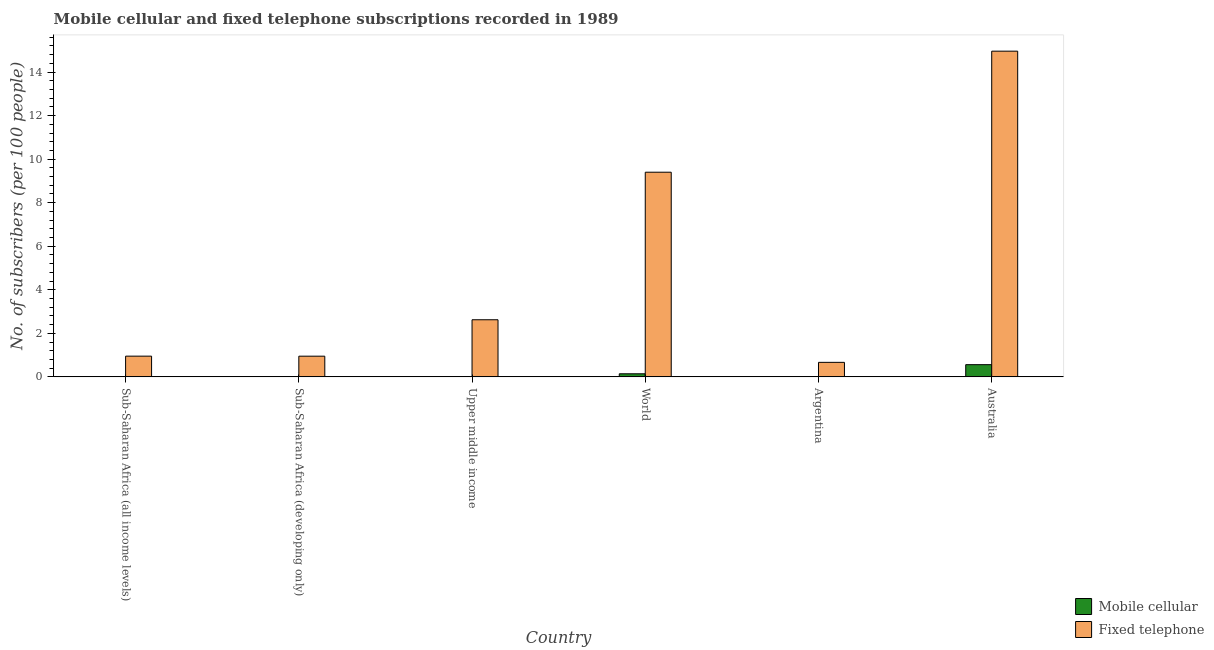How many different coloured bars are there?
Provide a short and direct response. 2. How many groups of bars are there?
Give a very brief answer. 6. Are the number of bars on each tick of the X-axis equal?
Your response must be concise. Yes. How many bars are there on the 3rd tick from the left?
Offer a very short reply. 2. How many bars are there on the 3rd tick from the right?
Provide a short and direct response. 2. What is the number of fixed telephone subscribers in Upper middle income?
Ensure brevity in your answer.  2.62. Across all countries, what is the maximum number of fixed telephone subscribers?
Make the answer very short. 14.96. Across all countries, what is the minimum number of fixed telephone subscribers?
Offer a very short reply. 0.67. What is the total number of fixed telephone subscribers in the graph?
Your response must be concise. 29.55. What is the difference between the number of mobile cellular subscribers in Australia and that in World?
Offer a very short reply. 0.42. What is the difference between the number of fixed telephone subscribers in Sub-Saharan Africa (all income levels) and the number of mobile cellular subscribers in Argentina?
Make the answer very short. 0.94. What is the average number of fixed telephone subscribers per country?
Ensure brevity in your answer.  4.93. What is the difference between the number of mobile cellular subscribers and number of fixed telephone subscribers in World?
Your answer should be very brief. -9.26. In how many countries, is the number of fixed telephone subscribers greater than 4.4 ?
Offer a very short reply. 2. What is the ratio of the number of fixed telephone subscribers in Australia to that in Sub-Saharan Africa (developing only)?
Your answer should be compact. 15.74. Is the difference between the number of mobile cellular subscribers in Australia and Upper middle income greater than the difference between the number of fixed telephone subscribers in Australia and Upper middle income?
Your answer should be very brief. No. What is the difference between the highest and the second highest number of mobile cellular subscribers?
Your response must be concise. 0.42. What is the difference between the highest and the lowest number of fixed telephone subscribers?
Your response must be concise. 14.29. In how many countries, is the number of fixed telephone subscribers greater than the average number of fixed telephone subscribers taken over all countries?
Offer a very short reply. 2. Is the sum of the number of fixed telephone subscribers in Argentina and Australia greater than the maximum number of mobile cellular subscribers across all countries?
Provide a succinct answer. Yes. What does the 1st bar from the left in Upper middle income represents?
Give a very brief answer. Mobile cellular. What does the 1st bar from the right in Sub-Saharan Africa (all income levels) represents?
Ensure brevity in your answer.  Fixed telephone. How many bars are there?
Keep it short and to the point. 12. Are all the bars in the graph horizontal?
Offer a terse response. No. How many countries are there in the graph?
Provide a succinct answer. 6. Does the graph contain grids?
Provide a succinct answer. No. How many legend labels are there?
Give a very brief answer. 2. How are the legend labels stacked?
Your answer should be very brief. Vertical. What is the title of the graph?
Make the answer very short. Mobile cellular and fixed telephone subscriptions recorded in 1989. What is the label or title of the Y-axis?
Ensure brevity in your answer.  No. of subscribers (per 100 people). What is the No. of subscribers (per 100 people) in Mobile cellular in Sub-Saharan Africa (all income levels)?
Provide a short and direct response. 0. What is the No. of subscribers (per 100 people) in Fixed telephone in Sub-Saharan Africa (all income levels)?
Give a very brief answer. 0.95. What is the No. of subscribers (per 100 people) of Mobile cellular in Sub-Saharan Africa (developing only)?
Provide a succinct answer. 0. What is the No. of subscribers (per 100 people) in Fixed telephone in Sub-Saharan Africa (developing only)?
Offer a very short reply. 0.95. What is the No. of subscribers (per 100 people) of Mobile cellular in Upper middle income?
Give a very brief answer. 0.01. What is the No. of subscribers (per 100 people) of Fixed telephone in Upper middle income?
Make the answer very short. 2.62. What is the No. of subscribers (per 100 people) of Mobile cellular in World?
Your response must be concise. 0.14. What is the No. of subscribers (per 100 people) of Fixed telephone in World?
Make the answer very short. 9.4. What is the No. of subscribers (per 100 people) of Mobile cellular in Argentina?
Your answer should be compact. 0.01. What is the No. of subscribers (per 100 people) of Fixed telephone in Argentina?
Provide a short and direct response. 0.67. What is the No. of subscribers (per 100 people) of Mobile cellular in Australia?
Your answer should be compact. 0.56. What is the No. of subscribers (per 100 people) in Fixed telephone in Australia?
Keep it short and to the point. 14.96. Across all countries, what is the maximum No. of subscribers (per 100 people) in Mobile cellular?
Ensure brevity in your answer.  0.56. Across all countries, what is the maximum No. of subscribers (per 100 people) of Fixed telephone?
Keep it short and to the point. 14.96. Across all countries, what is the minimum No. of subscribers (per 100 people) in Mobile cellular?
Make the answer very short. 0. Across all countries, what is the minimum No. of subscribers (per 100 people) of Fixed telephone?
Provide a short and direct response. 0.67. What is the total No. of subscribers (per 100 people) of Mobile cellular in the graph?
Ensure brevity in your answer.  0.72. What is the total No. of subscribers (per 100 people) of Fixed telephone in the graph?
Offer a terse response. 29.55. What is the difference between the No. of subscribers (per 100 people) in Fixed telephone in Sub-Saharan Africa (all income levels) and that in Sub-Saharan Africa (developing only)?
Your answer should be compact. 0. What is the difference between the No. of subscribers (per 100 people) in Mobile cellular in Sub-Saharan Africa (all income levels) and that in Upper middle income?
Offer a terse response. -0.01. What is the difference between the No. of subscribers (per 100 people) in Fixed telephone in Sub-Saharan Africa (all income levels) and that in Upper middle income?
Your response must be concise. -1.67. What is the difference between the No. of subscribers (per 100 people) of Mobile cellular in Sub-Saharan Africa (all income levels) and that in World?
Ensure brevity in your answer.  -0.14. What is the difference between the No. of subscribers (per 100 people) of Fixed telephone in Sub-Saharan Africa (all income levels) and that in World?
Keep it short and to the point. -8.45. What is the difference between the No. of subscribers (per 100 people) of Mobile cellular in Sub-Saharan Africa (all income levels) and that in Argentina?
Offer a very short reply. -0.01. What is the difference between the No. of subscribers (per 100 people) in Fixed telephone in Sub-Saharan Africa (all income levels) and that in Argentina?
Make the answer very short. 0.28. What is the difference between the No. of subscribers (per 100 people) of Mobile cellular in Sub-Saharan Africa (all income levels) and that in Australia?
Your answer should be very brief. -0.56. What is the difference between the No. of subscribers (per 100 people) in Fixed telephone in Sub-Saharan Africa (all income levels) and that in Australia?
Provide a short and direct response. -14.01. What is the difference between the No. of subscribers (per 100 people) in Mobile cellular in Sub-Saharan Africa (developing only) and that in Upper middle income?
Offer a very short reply. -0.01. What is the difference between the No. of subscribers (per 100 people) of Fixed telephone in Sub-Saharan Africa (developing only) and that in Upper middle income?
Give a very brief answer. -1.67. What is the difference between the No. of subscribers (per 100 people) of Mobile cellular in Sub-Saharan Africa (developing only) and that in World?
Give a very brief answer. -0.14. What is the difference between the No. of subscribers (per 100 people) of Fixed telephone in Sub-Saharan Africa (developing only) and that in World?
Ensure brevity in your answer.  -8.45. What is the difference between the No. of subscribers (per 100 people) in Mobile cellular in Sub-Saharan Africa (developing only) and that in Argentina?
Provide a short and direct response. -0.01. What is the difference between the No. of subscribers (per 100 people) of Fixed telephone in Sub-Saharan Africa (developing only) and that in Argentina?
Provide a succinct answer. 0.28. What is the difference between the No. of subscribers (per 100 people) in Mobile cellular in Sub-Saharan Africa (developing only) and that in Australia?
Your response must be concise. -0.56. What is the difference between the No. of subscribers (per 100 people) of Fixed telephone in Sub-Saharan Africa (developing only) and that in Australia?
Provide a succinct answer. -14.01. What is the difference between the No. of subscribers (per 100 people) in Mobile cellular in Upper middle income and that in World?
Your response must be concise. -0.14. What is the difference between the No. of subscribers (per 100 people) of Fixed telephone in Upper middle income and that in World?
Provide a succinct answer. -6.78. What is the difference between the No. of subscribers (per 100 people) of Mobile cellular in Upper middle income and that in Argentina?
Your answer should be very brief. -0. What is the difference between the No. of subscribers (per 100 people) in Fixed telephone in Upper middle income and that in Argentina?
Offer a very short reply. 1.96. What is the difference between the No. of subscribers (per 100 people) in Mobile cellular in Upper middle income and that in Australia?
Your answer should be very brief. -0.55. What is the difference between the No. of subscribers (per 100 people) in Fixed telephone in Upper middle income and that in Australia?
Provide a succinct answer. -12.34. What is the difference between the No. of subscribers (per 100 people) in Mobile cellular in World and that in Argentina?
Offer a very short reply. 0.13. What is the difference between the No. of subscribers (per 100 people) in Fixed telephone in World and that in Argentina?
Ensure brevity in your answer.  8.73. What is the difference between the No. of subscribers (per 100 people) of Mobile cellular in World and that in Australia?
Give a very brief answer. -0.42. What is the difference between the No. of subscribers (per 100 people) in Fixed telephone in World and that in Australia?
Provide a short and direct response. -5.56. What is the difference between the No. of subscribers (per 100 people) of Mobile cellular in Argentina and that in Australia?
Keep it short and to the point. -0.55. What is the difference between the No. of subscribers (per 100 people) in Fixed telephone in Argentina and that in Australia?
Make the answer very short. -14.29. What is the difference between the No. of subscribers (per 100 people) of Mobile cellular in Sub-Saharan Africa (all income levels) and the No. of subscribers (per 100 people) of Fixed telephone in Sub-Saharan Africa (developing only)?
Ensure brevity in your answer.  -0.95. What is the difference between the No. of subscribers (per 100 people) in Mobile cellular in Sub-Saharan Africa (all income levels) and the No. of subscribers (per 100 people) in Fixed telephone in Upper middle income?
Provide a succinct answer. -2.62. What is the difference between the No. of subscribers (per 100 people) of Mobile cellular in Sub-Saharan Africa (all income levels) and the No. of subscribers (per 100 people) of Fixed telephone in World?
Your answer should be compact. -9.4. What is the difference between the No. of subscribers (per 100 people) of Mobile cellular in Sub-Saharan Africa (all income levels) and the No. of subscribers (per 100 people) of Fixed telephone in Argentina?
Provide a succinct answer. -0.67. What is the difference between the No. of subscribers (per 100 people) of Mobile cellular in Sub-Saharan Africa (all income levels) and the No. of subscribers (per 100 people) of Fixed telephone in Australia?
Your response must be concise. -14.96. What is the difference between the No. of subscribers (per 100 people) of Mobile cellular in Sub-Saharan Africa (developing only) and the No. of subscribers (per 100 people) of Fixed telephone in Upper middle income?
Offer a terse response. -2.62. What is the difference between the No. of subscribers (per 100 people) in Mobile cellular in Sub-Saharan Africa (developing only) and the No. of subscribers (per 100 people) in Fixed telephone in World?
Provide a succinct answer. -9.4. What is the difference between the No. of subscribers (per 100 people) in Mobile cellular in Sub-Saharan Africa (developing only) and the No. of subscribers (per 100 people) in Fixed telephone in Argentina?
Offer a terse response. -0.67. What is the difference between the No. of subscribers (per 100 people) in Mobile cellular in Sub-Saharan Africa (developing only) and the No. of subscribers (per 100 people) in Fixed telephone in Australia?
Make the answer very short. -14.96. What is the difference between the No. of subscribers (per 100 people) of Mobile cellular in Upper middle income and the No. of subscribers (per 100 people) of Fixed telephone in World?
Your response must be concise. -9.39. What is the difference between the No. of subscribers (per 100 people) in Mobile cellular in Upper middle income and the No. of subscribers (per 100 people) in Fixed telephone in Argentina?
Offer a terse response. -0.66. What is the difference between the No. of subscribers (per 100 people) in Mobile cellular in Upper middle income and the No. of subscribers (per 100 people) in Fixed telephone in Australia?
Your answer should be very brief. -14.95. What is the difference between the No. of subscribers (per 100 people) in Mobile cellular in World and the No. of subscribers (per 100 people) in Fixed telephone in Argentina?
Offer a terse response. -0.52. What is the difference between the No. of subscribers (per 100 people) of Mobile cellular in World and the No. of subscribers (per 100 people) of Fixed telephone in Australia?
Ensure brevity in your answer.  -14.82. What is the difference between the No. of subscribers (per 100 people) of Mobile cellular in Argentina and the No. of subscribers (per 100 people) of Fixed telephone in Australia?
Your response must be concise. -14.95. What is the average No. of subscribers (per 100 people) in Mobile cellular per country?
Your answer should be very brief. 0.12. What is the average No. of subscribers (per 100 people) of Fixed telephone per country?
Give a very brief answer. 4.93. What is the difference between the No. of subscribers (per 100 people) in Mobile cellular and No. of subscribers (per 100 people) in Fixed telephone in Sub-Saharan Africa (all income levels)?
Make the answer very short. -0.95. What is the difference between the No. of subscribers (per 100 people) of Mobile cellular and No. of subscribers (per 100 people) of Fixed telephone in Sub-Saharan Africa (developing only)?
Provide a succinct answer. -0.95. What is the difference between the No. of subscribers (per 100 people) in Mobile cellular and No. of subscribers (per 100 people) in Fixed telephone in Upper middle income?
Make the answer very short. -2.62. What is the difference between the No. of subscribers (per 100 people) in Mobile cellular and No. of subscribers (per 100 people) in Fixed telephone in World?
Your response must be concise. -9.26. What is the difference between the No. of subscribers (per 100 people) in Mobile cellular and No. of subscribers (per 100 people) in Fixed telephone in Argentina?
Give a very brief answer. -0.66. What is the difference between the No. of subscribers (per 100 people) in Mobile cellular and No. of subscribers (per 100 people) in Fixed telephone in Australia?
Provide a succinct answer. -14.4. What is the ratio of the No. of subscribers (per 100 people) in Fixed telephone in Sub-Saharan Africa (all income levels) to that in Sub-Saharan Africa (developing only)?
Provide a succinct answer. 1. What is the ratio of the No. of subscribers (per 100 people) of Mobile cellular in Sub-Saharan Africa (all income levels) to that in Upper middle income?
Offer a very short reply. 0.13. What is the ratio of the No. of subscribers (per 100 people) in Fixed telephone in Sub-Saharan Africa (all income levels) to that in Upper middle income?
Your answer should be very brief. 0.36. What is the ratio of the No. of subscribers (per 100 people) in Mobile cellular in Sub-Saharan Africa (all income levels) to that in World?
Ensure brevity in your answer.  0.01. What is the ratio of the No. of subscribers (per 100 people) in Fixed telephone in Sub-Saharan Africa (all income levels) to that in World?
Make the answer very short. 0.1. What is the ratio of the No. of subscribers (per 100 people) in Mobile cellular in Sub-Saharan Africa (all income levels) to that in Argentina?
Your answer should be compact. 0.11. What is the ratio of the No. of subscribers (per 100 people) in Fixed telephone in Sub-Saharan Africa (all income levels) to that in Argentina?
Keep it short and to the point. 1.43. What is the ratio of the No. of subscribers (per 100 people) in Mobile cellular in Sub-Saharan Africa (all income levels) to that in Australia?
Provide a short and direct response. 0. What is the ratio of the No. of subscribers (per 100 people) in Fixed telephone in Sub-Saharan Africa (all income levels) to that in Australia?
Offer a terse response. 0.06. What is the ratio of the No. of subscribers (per 100 people) of Mobile cellular in Sub-Saharan Africa (developing only) to that in Upper middle income?
Your response must be concise. 0.13. What is the ratio of the No. of subscribers (per 100 people) in Fixed telephone in Sub-Saharan Africa (developing only) to that in Upper middle income?
Your response must be concise. 0.36. What is the ratio of the No. of subscribers (per 100 people) in Mobile cellular in Sub-Saharan Africa (developing only) to that in World?
Offer a terse response. 0.01. What is the ratio of the No. of subscribers (per 100 people) of Fixed telephone in Sub-Saharan Africa (developing only) to that in World?
Ensure brevity in your answer.  0.1. What is the ratio of the No. of subscribers (per 100 people) of Mobile cellular in Sub-Saharan Africa (developing only) to that in Argentina?
Provide a succinct answer. 0.11. What is the ratio of the No. of subscribers (per 100 people) of Fixed telephone in Sub-Saharan Africa (developing only) to that in Argentina?
Offer a terse response. 1.43. What is the ratio of the No. of subscribers (per 100 people) of Mobile cellular in Sub-Saharan Africa (developing only) to that in Australia?
Ensure brevity in your answer.  0. What is the ratio of the No. of subscribers (per 100 people) in Fixed telephone in Sub-Saharan Africa (developing only) to that in Australia?
Offer a very short reply. 0.06. What is the ratio of the No. of subscribers (per 100 people) of Mobile cellular in Upper middle income to that in World?
Provide a short and direct response. 0.05. What is the ratio of the No. of subscribers (per 100 people) of Fixed telephone in Upper middle income to that in World?
Keep it short and to the point. 0.28. What is the ratio of the No. of subscribers (per 100 people) of Mobile cellular in Upper middle income to that in Argentina?
Your answer should be very brief. 0.9. What is the ratio of the No. of subscribers (per 100 people) of Fixed telephone in Upper middle income to that in Argentina?
Provide a succinct answer. 3.94. What is the ratio of the No. of subscribers (per 100 people) of Mobile cellular in Upper middle income to that in Australia?
Your answer should be very brief. 0.01. What is the ratio of the No. of subscribers (per 100 people) of Fixed telephone in Upper middle income to that in Australia?
Offer a terse response. 0.18. What is the ratio of the No. of subscribers (per 100 people) in Mobile cellular in World to that in Argentina?
Offer a terse response. 19.82. What is the ratio of the No. of subscribers (per 100 people) of Fixed telephone in World to that in Argentina?
Give a very brief answer. 14.1. What is the ratio of the No. of subscribers (per 100 people) of Mobile cellular in World to that in Australia?
Provide a succinct answer. 0.25. What is the ratio of the No. of subscribers (per 100 people) in Fixed telephone in World to that in Australia?
Your answer should be compact. 0.63. What is the ratio of the No. of subscribers (per 100 people) in Mobile cellular in Argentina to that in Australia?
Ensure brevity in your answer.  0.01. What is the ratio of the No. of subscribers (per 100 people) in Fixed telephone in Argentina to that in Australia?
Ensure brevity in your answer.  0.04. What is the difference between the highest and the second highest No. of subscribers (per 100 people) of Mobile cellular?
Provide a succinct answer. 0.42. What is the difference between the highest and the second highest No. of subscribers (per 100 people) of Fixed telephone?
Offer a terse response. 5.56. What is the difference between the highest and the lowest No. of subscribers (per 100 people) of Mobile cellular?
Your answer should be compact. 0.56. What is the difference between the highest and the lowest No. of subscribers (per 100 people) of Fixed telephone?
Your answer should be very brief. 14.29. 